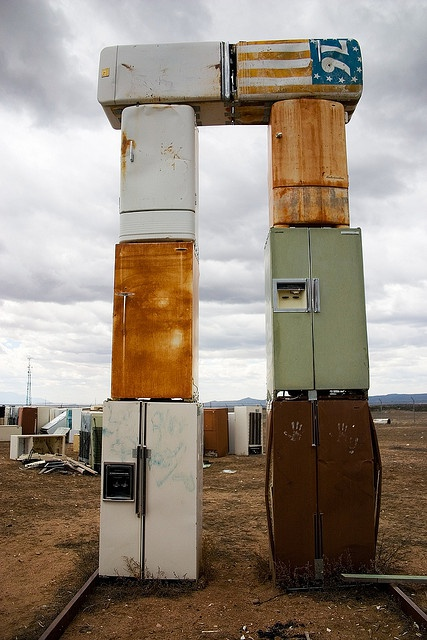Describe the objects in this image and their specific colors. I can see refrigerator in gray, black, and maroon tones, refrigerator in gray, darkgray, and black tones, refrigerator in gray, darkgray, and black tones, refrigerator in gray, brown, maroon, and black tones, and refrigerator in gray, darkgray, and lightgray tones in this image. 